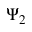<formula> <loc_0><loc_0><loc_500><loc_500>\Psi _ { 2 }</formula> 